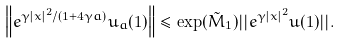<formula> <loc_0><loc_0><loc_500><loc_500>\left \| e ^ { \gamma | x | ^ { 2 } / ( 1 + 4 \gamma a ) } u _ { a } ( 1 ) \right \| \leq \exp ( \tilde { M } _ { 1 } ) | | e ^ { \gamma | x | ^ { 2 } } u ( 1 ) | | .</formula> 